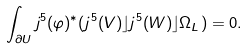<formula> <loc_0><loc_0><loc_500><loc_500>\int _ { \partial U } { j ^ { 5 } ( \varphi ) ^ { \ast } ( j ^ { 5 } ( V ) \rfloor j ^ { 5 } ( W ) \rfloor \Omega _ { L } ) } = 0 .</formula> 